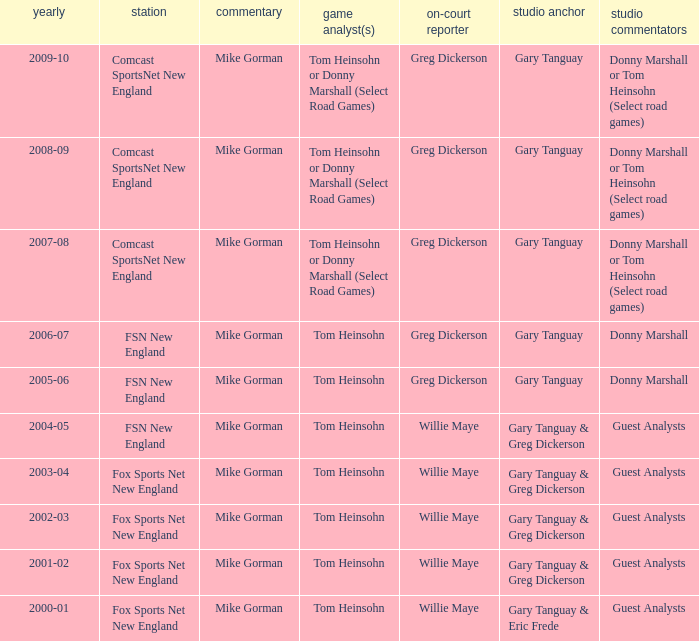Which Courtside reporter has a Channel of fsn new england in 2006-07? Greg Dickerson. 